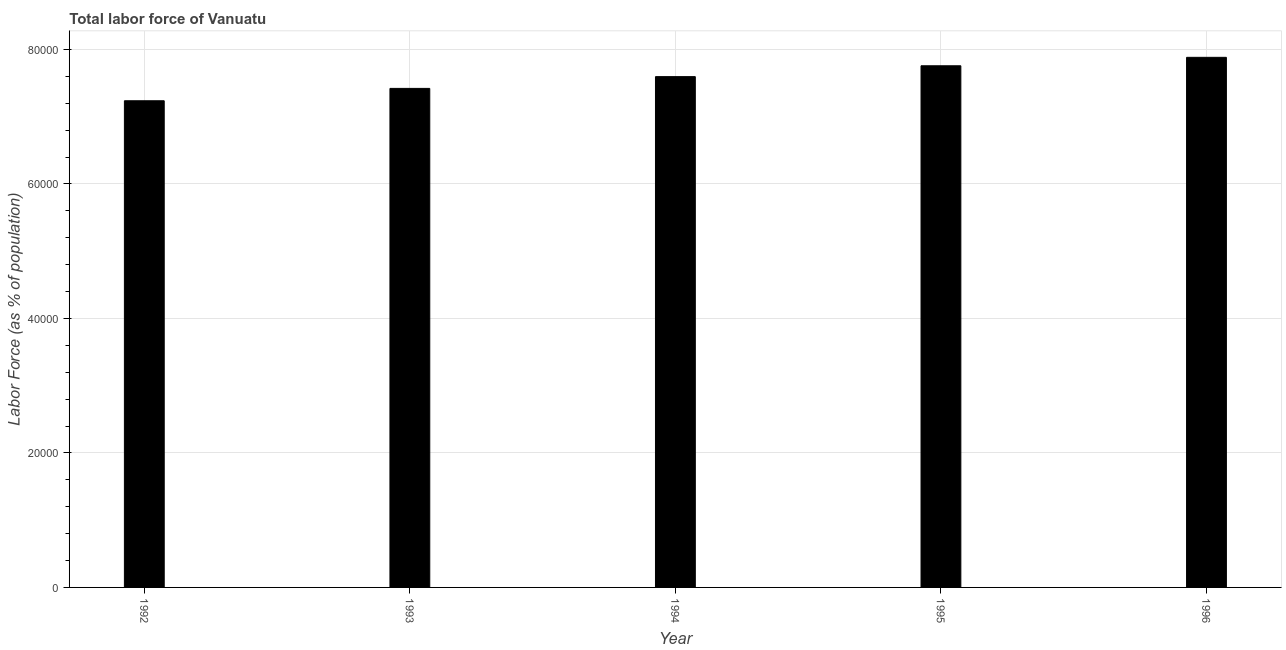Does the graph contain any zero values?
Keep it short and to the point. No. Does the graph contain grids?
Offer a very short reply. Yes. What is the title of the graph?
Your answer should be compact. Total labor force of Vanuatu. What is the label or title of the X-axis?
Your answer should be compact. Year. What is the label or title of the Y-axis?
Ensure brevity in your answer.  Labor Force (as % of population). What is the total labor force in 1994?
Make the answer very short. 7.60e+04. Across all years, what is the maximum total labor force?
Your answer should be very brief. 7.88e+04. Across all years, what is the minimum total labor force?
Ensure brevity in your answer.  7.24e+04. In which year was the total labor force minimum?
Ensure brevity in your answer.  1992. What is the sum of the total labor force?
Keep it short and to the point. 3.79e+05. What is the difference between the total labor force in 1993 and 1996?
Provide a succinct answer. -4620. What is the average total labor force per year?
Give a very brief answer. 7.58e+04. What is the median total labor force?
Your response must be concise. 7.60e+04. In how many years, is the total labor force greater than 72000 %?
Offer a terse response. 5. Do a majority of the years between 1993 and 1995 (inclusive) have total labor force greater than 60000 %?
Your answer should be very brief. Yes. What is the ratio of the total labor force in 1993 to that in 1994?
Provide a short and direct response. 0.98. What is the difference between the highest and the second highest total labor force?
Keep it short and to the point. 1256. What is the difference between the highest and the lowest total labor force?
Make the answer very short. 6458. In how many years, is the total labor force greater than the average total labor force taken over all years?
Your response must be concise. 3. How many bars are there?
Provide a short and direct response. 5. Are all the bars in the graph horizontal?
Provide a succinct answer. No. How many years are there in the graph?
Provide a short and direct response. 5. What is the Labor Force (as % of population) of 1992?
Your response must be concise. 7.24e+04. What is the Labor Force (as % of population) in 1993?
Your answer should be very brief. 7.42e+04. What is the Labor Force (as % of population) of 1994?
Your response must be concise. 7.60e+04. What is the Labor Force (as % of population) of 1995?
Give a very brief answer. 7.76e+04. What is the Labor Force (as % of population) of 1996?
Ensure brevity in your answer.  7.88e+04. What is the difference between the Labor Force (as % of population) in 1992 and 1993?
Keep it short and to the point. -1838. What is the difference between the Labor Force (as % of population) in 1992 and 1994?
Provide a short and direct response. -3587. What is the difference between the Labor Force (as % of population) in 1992 and 1995?
Provide a succinct answer. -5202. What is the difference between the Labor Force (as % of population) in 1992 and 1996?
Your answer should be compact. -6458. What is the difference between the Labor Force (as % of population) in 1993 and 1994?
Offer a terse response. -1749. What is the difference between the Labor Force (as % of population) in 1993 and 1995?
Ensure brevity in your answer.  -3364. What is the difference between the Labor Force (as % of population) in 1993 and 1996?
Ensure brevity in your answer.  -4620. What is the difference between the Labor Force (as % of population) in 1994 and 1995?
Your answer should be very brief. -1615. What is the difference between the Labor Force (as % of population) in 1994 and 1996?
Give a very brief answer. -2871. What is the difference between the Labor Force (as % of population) in 1995 and 1996?
Keep it short and to the point. -1256. What is the ratio of the Labor Force (as % of population) in 1992 to that in 1993?
Provide a short and direct response. 0.97. What is the ratio of the Labor Force (as % of population) in 1992 to that in 1994?
Make the answer very short. 0.95. What is the ratio of the Labor Force (as % of population) in 1992 to that in 1995?
Offer a very short reply. 0.93. What is the ratio of the Labor Force (as % of population) in 1992 to that in 1996?
Your response must be concise. 0.92. What is the ratio of the Labor Force (as % of population) in 1993 to that in 1996?
Your answer should be compact. 0.94. What is the ratio of the Labor Force (as % of population) in 1994 to that in 1995?
Provide a succinct answer. 0.98. 